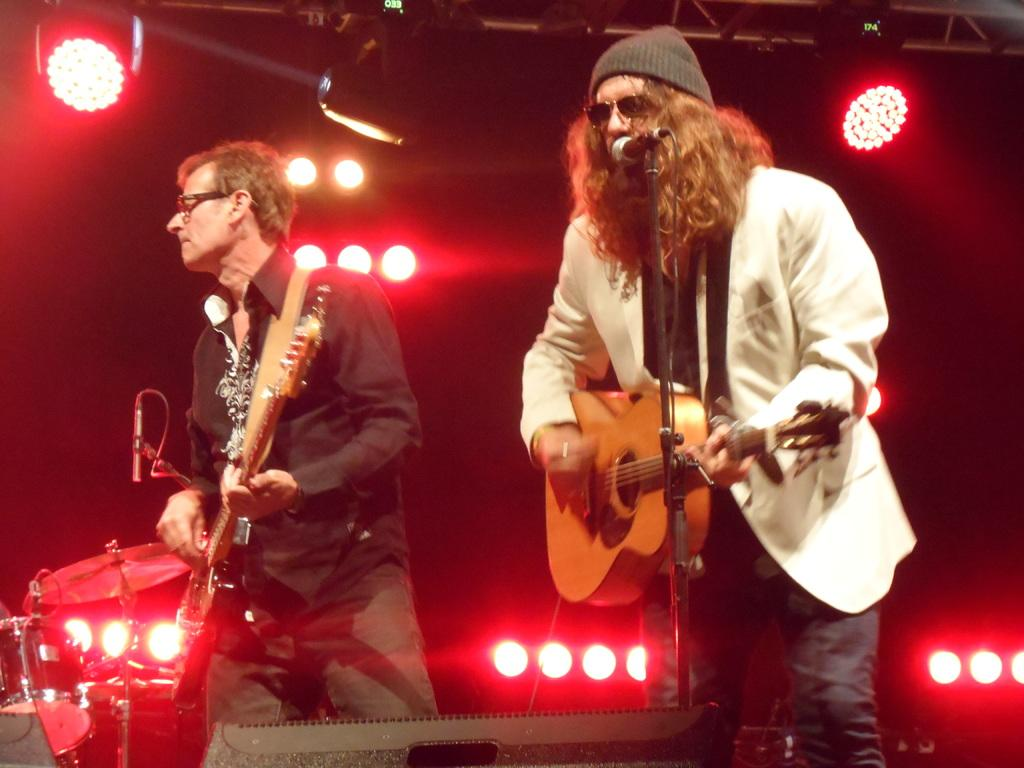How many people are in the image? There are two people in the image. What are the people doing in the image? The people are playing musical instruments. Can you describe the person on the right side of the image? The person on the right side is wearing a white color shirt and a cap. Can you tell me how many goldfish are swimming in the image? There are no goldfish present in the image; it features two people playing musical instruments. What type of instrument is the dad playing in the image? There is no mention of a dad or any specific person playing an instrument in the image; it only states that there are two people playing musical instruments. 